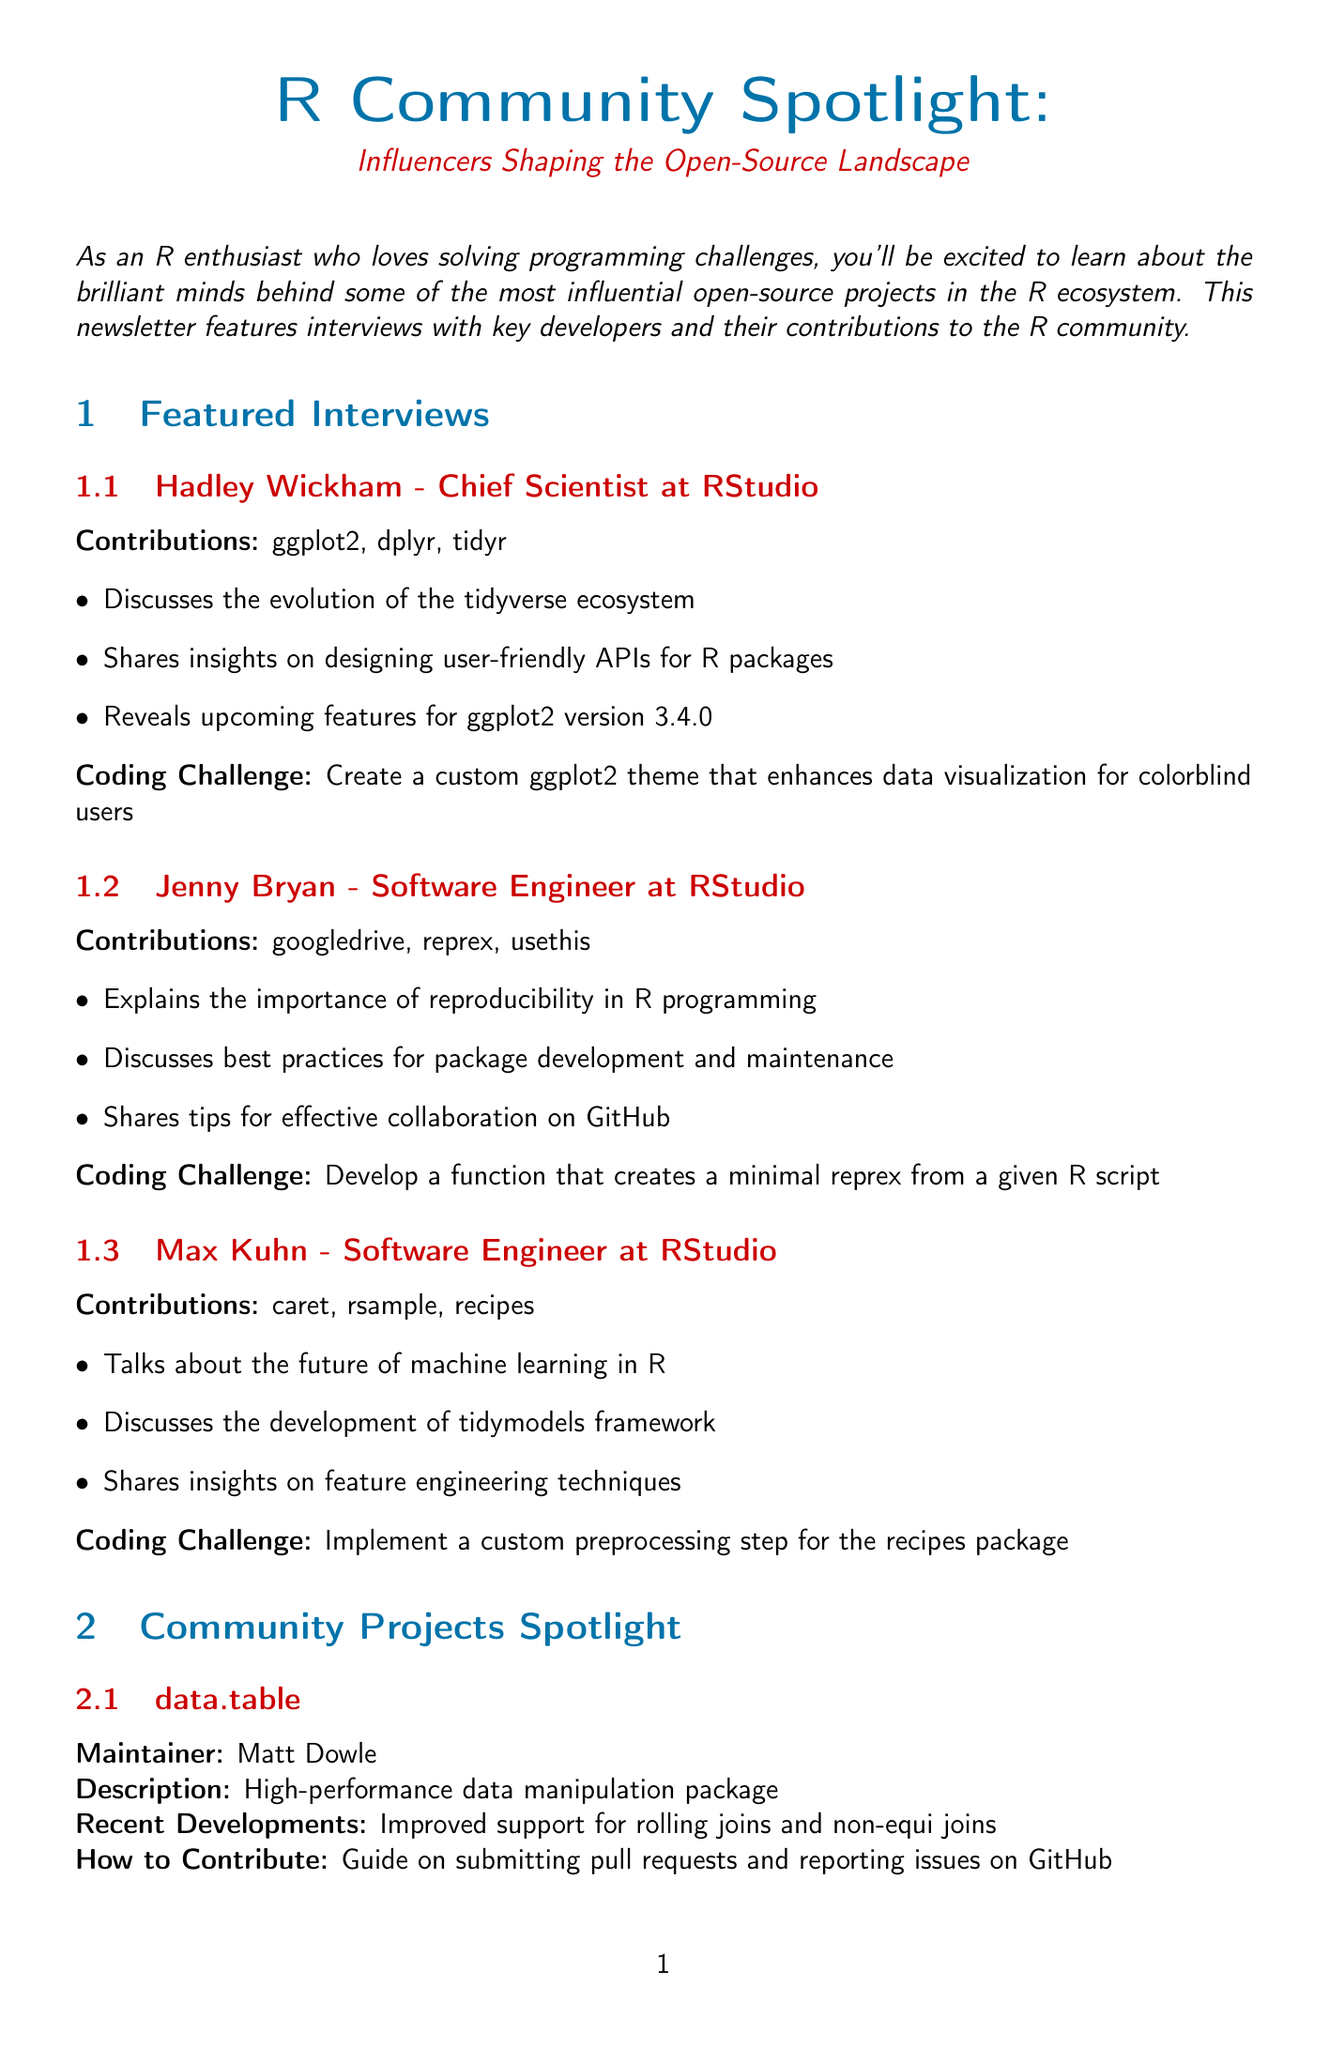What is the title of the newsletter? The title is a specific phrase at the beginning of the document that encapsulates the main theme of the content.
Answer: R Community Spotlight: Influencers Shaping the Open-Source Landscape Who is the Chief Scientist at RStudio? Refers to a specific individual mentioned in the interviews who holds the title within the organization.
Answer: Hadley Wickham What are the contributions of Jenny Bryan? This refers to the specific projects or packages that Jenny Bryan has worked on, as listed in the interview section.
Answer: googledrive, reprex, usethis What is the location of the useR! 2023 conference? This question asks for the geographic setting of the upcoming event as described in the document.
Answer: Basel, Switzerland What was introduced in the recent developments of shiny? This asks for a key update related to the shiny project mentioned in the community projects spotlight.
Answer: Introduction of shiny modules for better code organization What is the coding challenge given by Max Kuhn? The document describes specific challenges offered by the interviewees, which may require some reasoning to retrieve.
Answer: Implement a custom preprocessing step for the recipes package How many days is the rstudio::conf(2023)? This requires calculating or recalling the duration of the event based on how the dates are presented in the document.
Answer: Four days What are the names of the authors of "R for Data Science"? This seeks specific identity information relevant to a resource mentioned within the document.
Answer: Hadley Wickham and Garrett Grolemund 